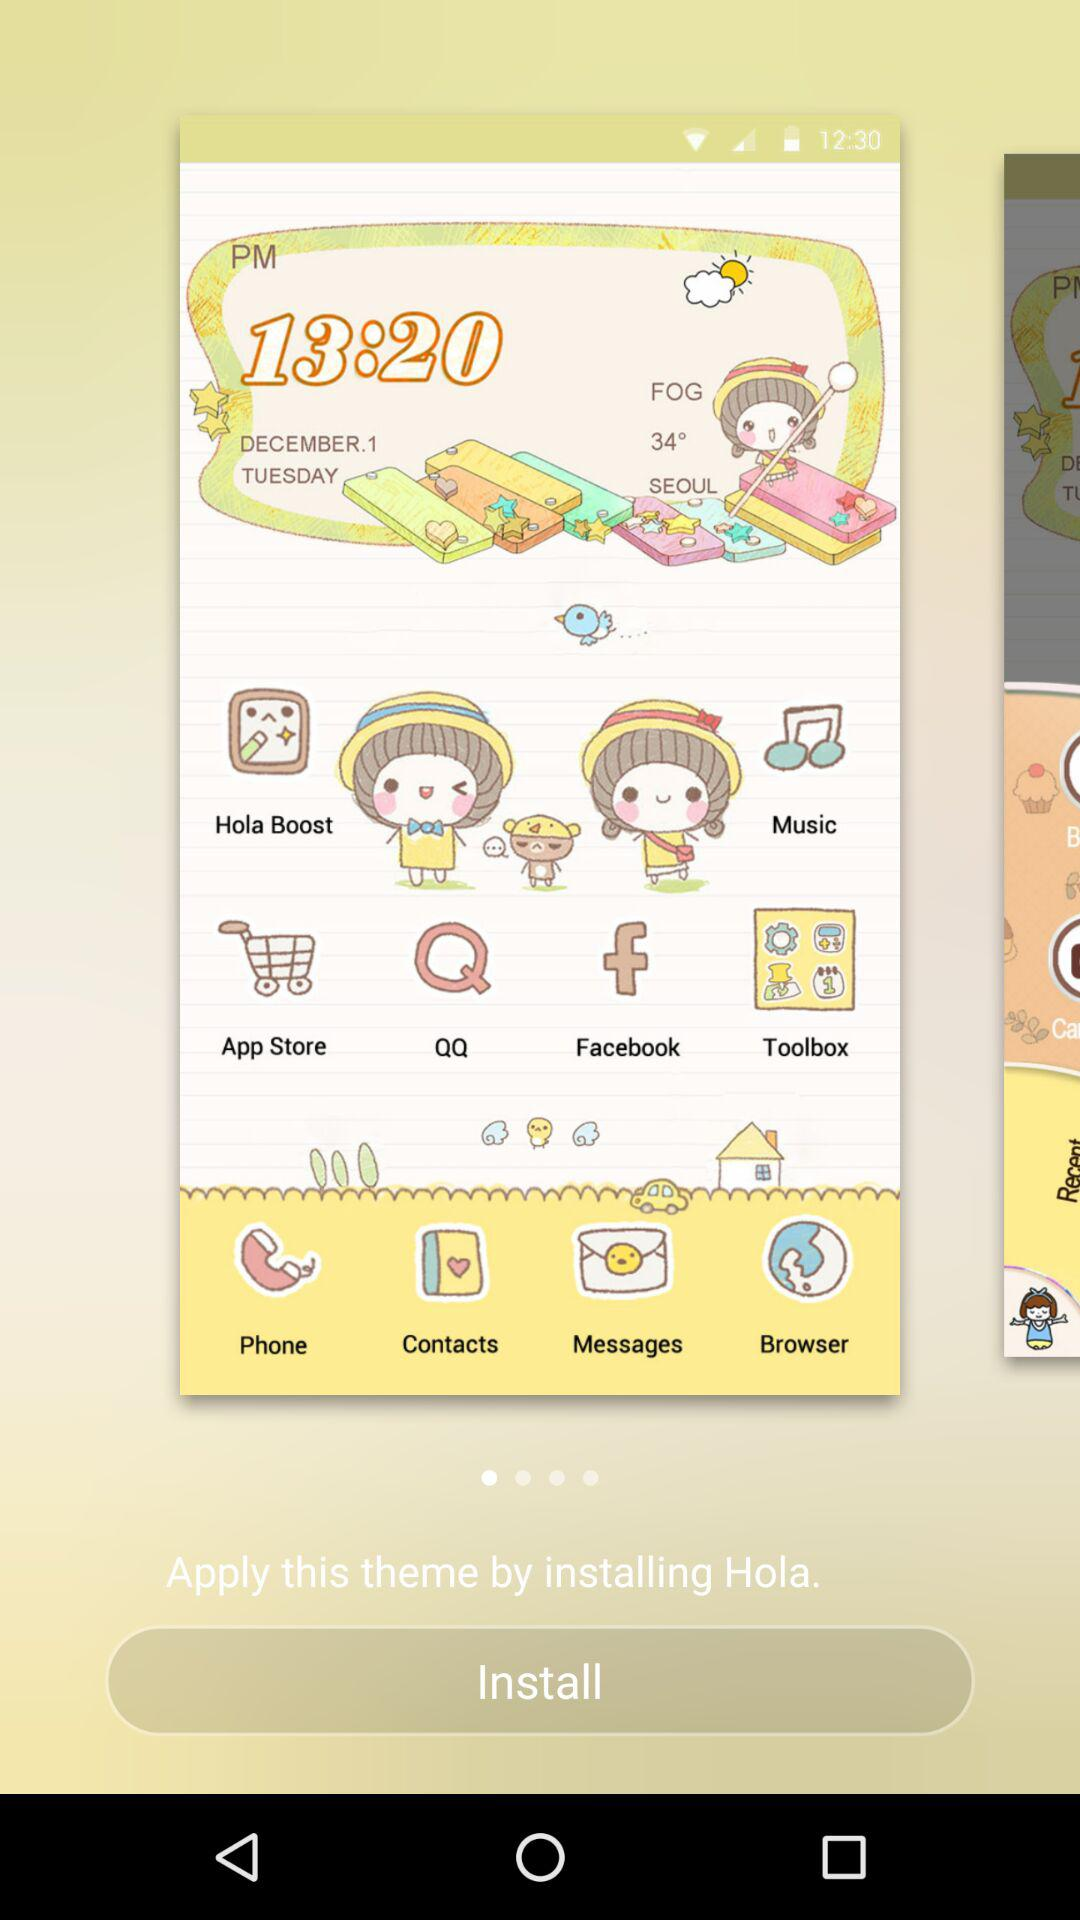What is the weather like? The weather is foggy. 